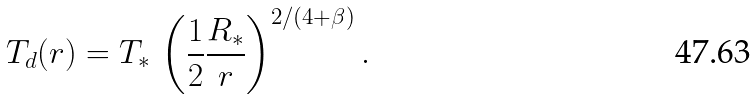<formula> <loc_0><loc_0><loc_500><loc_500>T _ { d } ( r ) = T _ { * } \, \left ( \frac { 1 } { 2 } \frac { R _ { \ast } } { r } \right ) ^ { 2 / ( 4 + \beta ) } .</formula> 